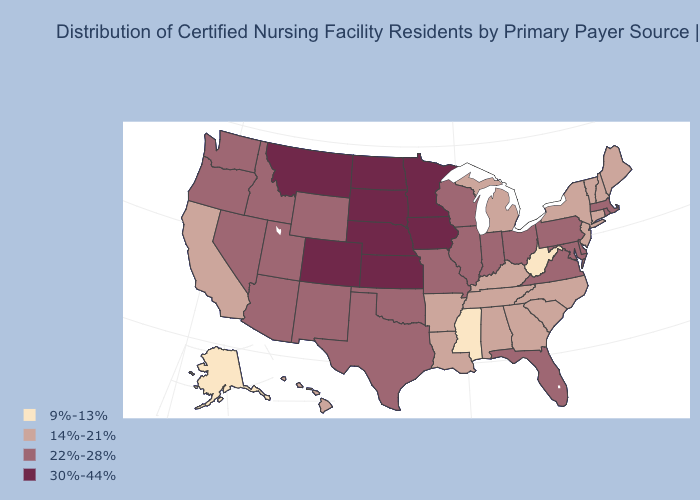Is the legend a continuous bar?
Quick response, please. No. What is the value of Arizona?
Write a very short answer. 22%-28%. Among the states that border Wisconsin , does Illinois have the lowest value?
Short answer required. No. Which states have the lowest value in the USA?
Give a very brief answer. Alaska, Mississippi, West Virginia. Among the states that border New Hampshire , which have the highest value?
Write a very short answer. Massachusetts. How many symbols are there in the legend?
Short answer required. 4. What is the highest value in the Northeast ?
Keep it brief. 22%-28%. Does the first symbol in the legend represent the smallest category?
Write a very short answer. Yes. Does Alaska have the lowest value in the West?
Concise answer only. Yes. What is the value of Louisiana?
Write a very short answer. 14%-21%. What is the lowest value in the USA?
Concise answer only. 9%-13%. Name the states that have a value in the range 14%-21%?
Answer briefly. Alabama, Arkansas, California, Connecticut, Georgia, Hawaii, Kentucky, Louisiana, Maine, Michigan, New Hampshire, New Jersey, New York, North Carolina, South Carolina, Tennessee, Vermont. What is the lowest value in states that border California?
Concise answer only. 22%-28%. What is the value of Delaware?
Be succinct. 22%-28%. What is the highest value in the West ?
Quick response, please. 30%-44%. 